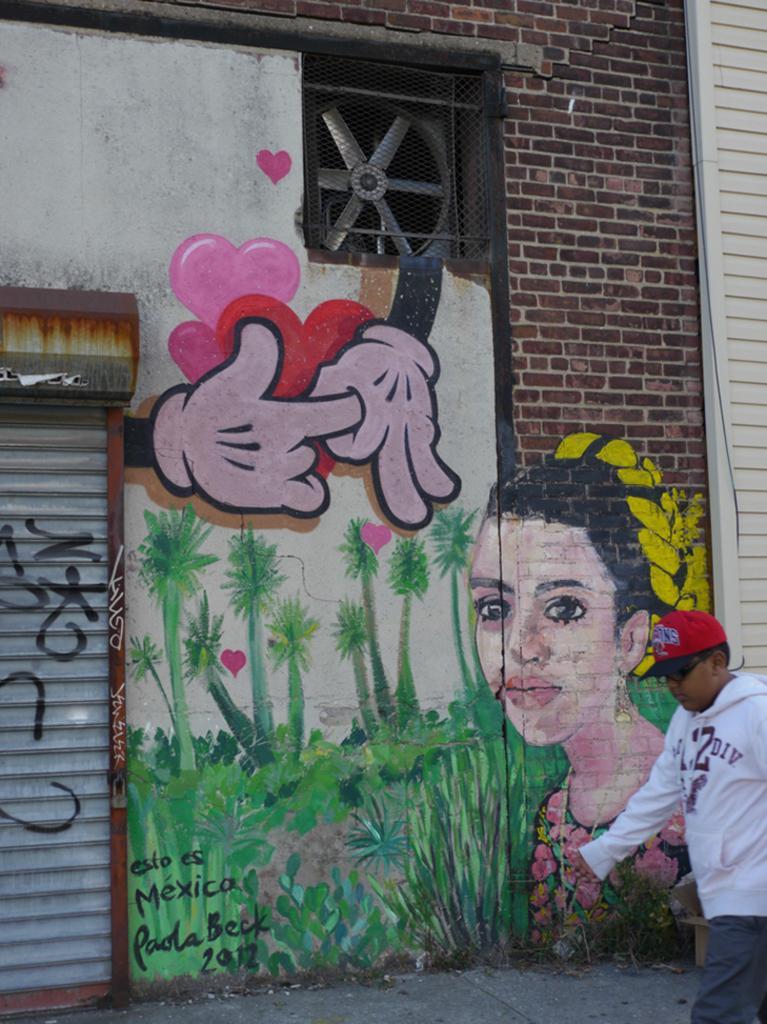How would you summarize this image in a sentence or two? In this picture there is a boy walking and we can see painting on the wall, shutter, mesh and exhaust fan. 